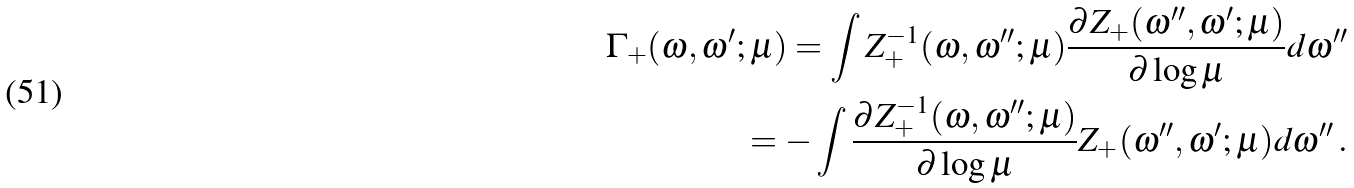Convert formula to latex. <formula><loc_0><loc_0><loc_500><loc_500>\Gamma _ { + } ( \omega , \omega ^ { \prime } ; \mu ) = \int Z _ { + } ^ { - 1 } ( \omega , \omega ^ { \prime \prime } ; \mu ) \frac { \partial Z _ { + } ( \omega ^ { \prime \prime } , \omega ^ { \prime } ; \mu ) } { \partial \log \mu } d \omega ^ { \prime \prime } \\ = - \int \frac { \partial Z _ { + } ^ { - 1 } ( \omega , \omega ^ { \prime \prime } ; \mu ) } { \partial \log \mu } Z _ { + } ( \omega ^ { \prime \prime } , \omega ^ { \prime } ; \mu ) d \omega ^ { \prime \prime } \, .</formula> 